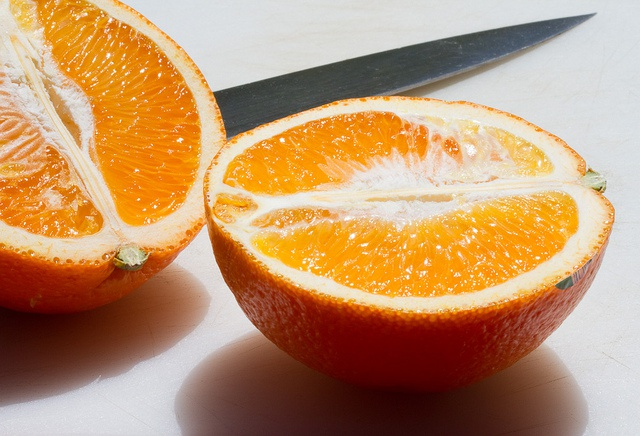Describe the objects in this image and their specific colors. I can see orange in tan, orange, ivory, and maroon tones, orange in tan, orange, and lightgray tones, and knife in tan, purple, and black tones in this image. 